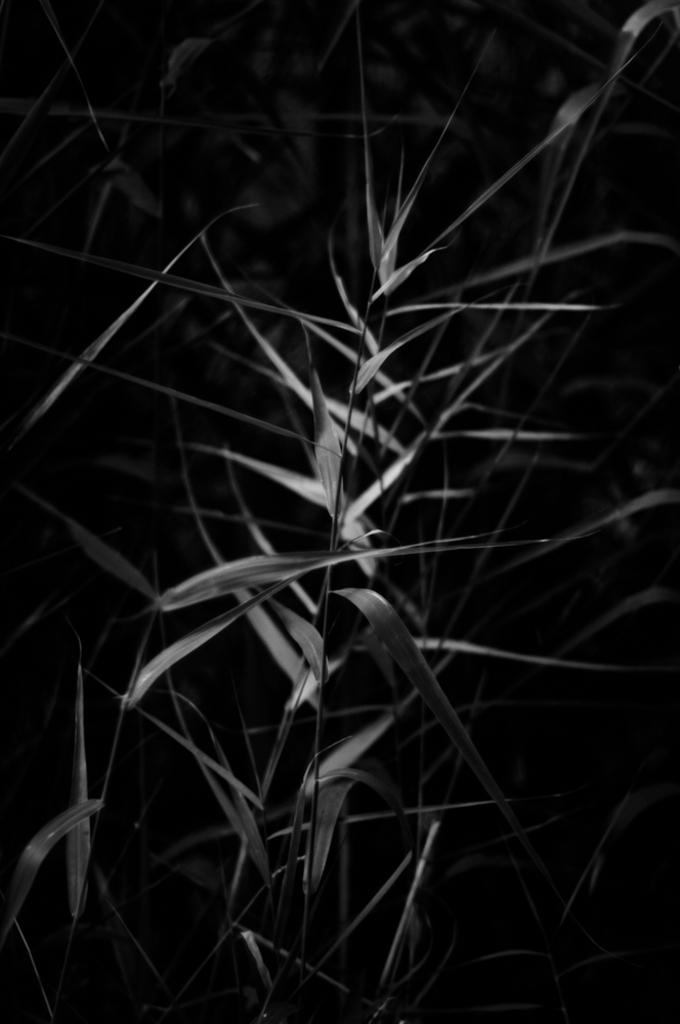What type of plant is depicted in the image? The image contains leaves of a plant. Can you describe the appearance of the leaves? The leaves are the visible part of the plant in the image. What might be the purpose of the plant? The purpose of the plant cannot be determined from the image alone. What type of corn is being harvested by the grandmother in the image? There is no corn or grandmother present in the image; it only contains leaves of a plant. How many ducks are swimming in the pond near the plant in the image? There is no pond or ducks present in the image; it only contains leaves of a plant. 